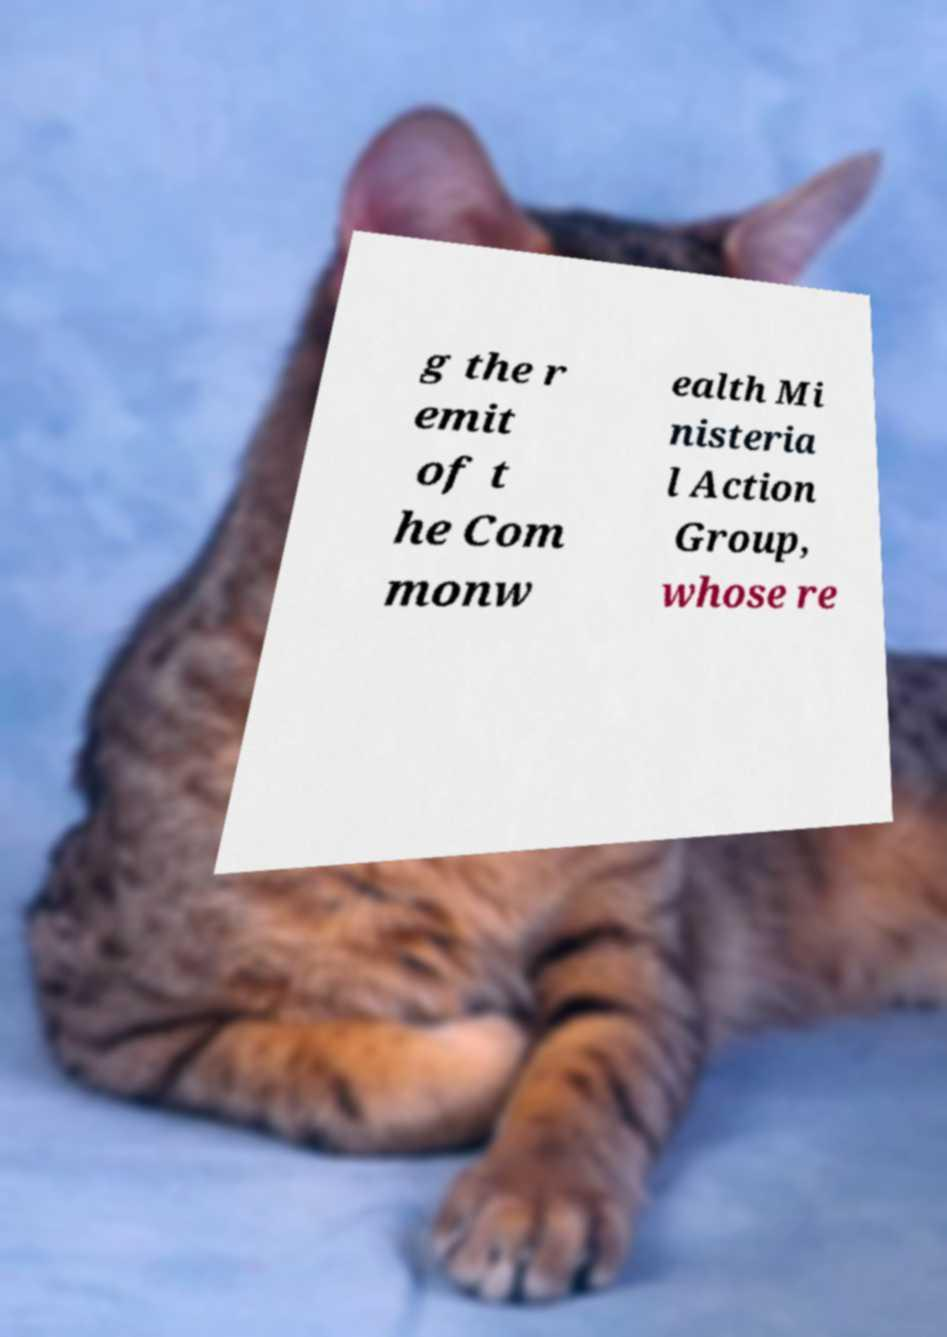Please identify and transcribe the text found in this image. g the r emit of t he Com monw ealth Mi nisteria l Action Group, whose re 